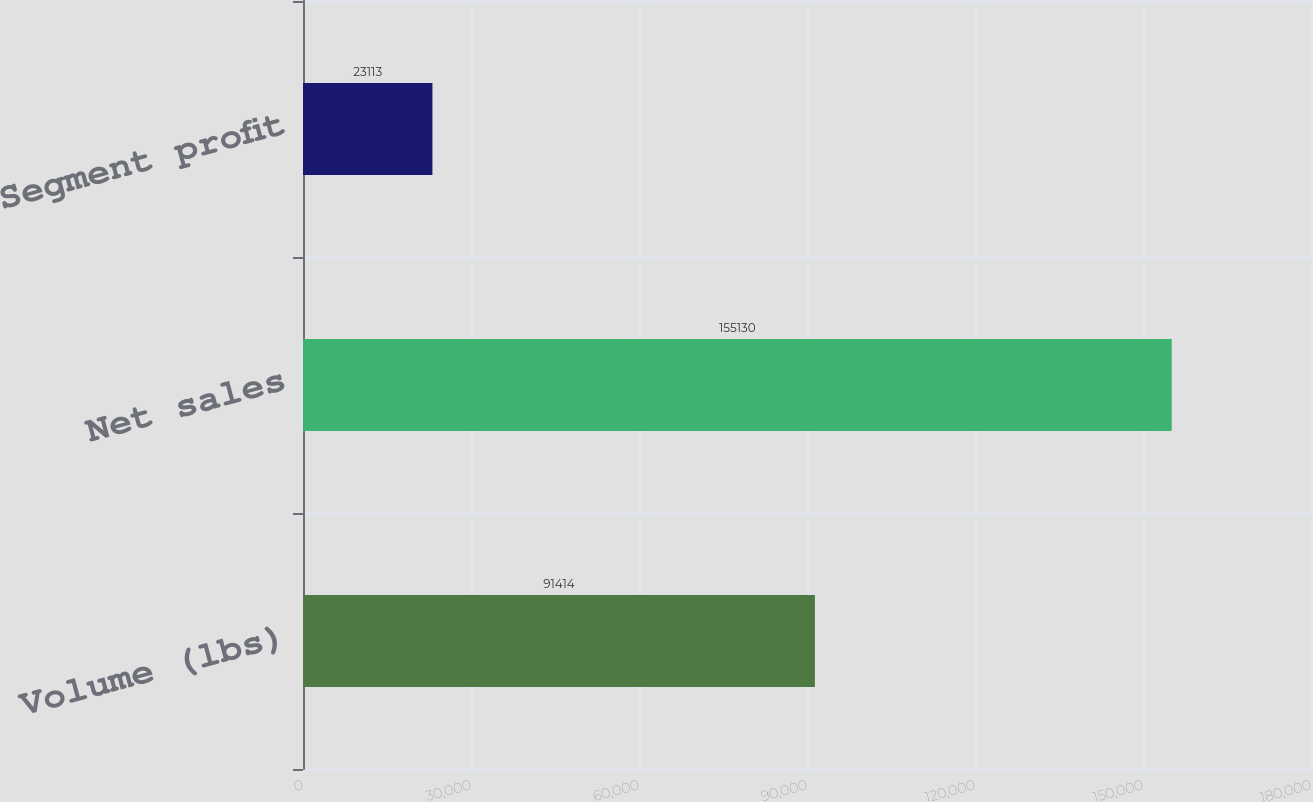<chart> <loc_0><loc_0><loc_500><loc_500><bar_chart><fcel>Volume (lbs)<fcel>Net sales<fcel>Segment profit<nl><fcel>91414<fcel>155130<fcel>23113<nl></chart> 